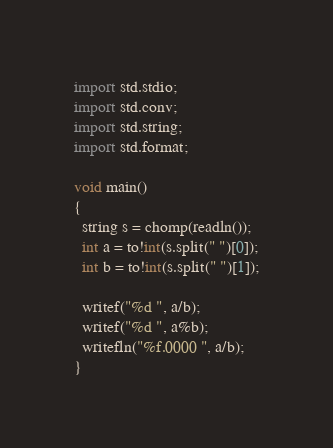<code> <loc_0><loc_0><loc_500><loc_500><_D_>import std.stdio;
import std.conv;
import std.string;
import std.format;

void main()
{
  string s = chomp(readln());
  int a = to!int(s.split(" ")[0]);
  int b = to!int(s.split(" ")[1]);
  
  writef("%d ", a/b);
  writef("%d ", a%b);
  writefln("%f.0000 ", a/b);
}</code> 